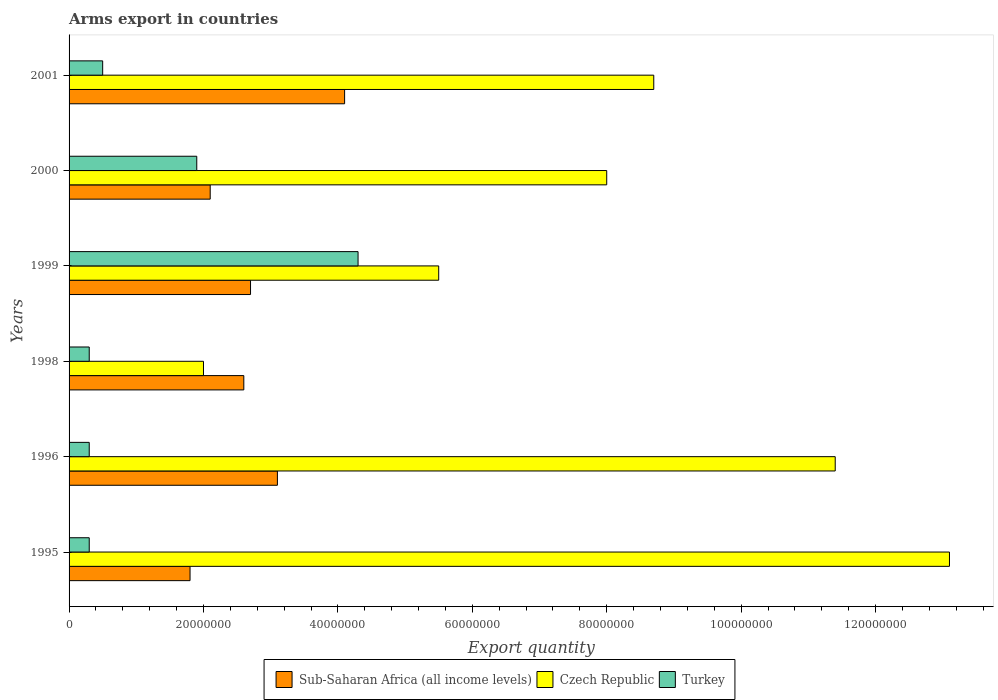How many groups of bars are there?
Give a very brief answer. 6. What is the label of the 4th group of bars from the top?
Your response must be concise. 1998. In how many cases, is the number of bars for a given year not equal to the number of legend labels?
Ensure brevity in your answer.  0. What is the total arms export in Sub-Saharan Africa (all income levels) in 1999?
Make the answer very short. 2.70e+07. Across all years, what is the maximum total arms export in Turkey?
Offer a very short reply. 4.30e+07. Across all years, what is the minimum total arms export in Sub-Saharan Africa (all income levels)?
Offer a very short reply. 1.80e+07. In which year was the total arms export in Turkey maximum?
Give a very brief answer. 1999. What is the total total arms export in Czech Republic in the graph?
Give a very brief answer. 4.87e+08. What is the difference between the total arms export in Sub-Saharan Africa (all income levels) in 2000 and that in 2001?
Your answer should be compact. -2.00e+07. What is the difference between the total arms export in Czech Republic in 2000 and the total arms export in Sub-Saharan Africa (all income levels) in 1998?
Your answer should be very brief. 5.40e+07. What is the average total arms export in Turkey per year?
Your response must be concise. 1.27e+07. In the year 1996, what is the difference between the total arms export in Czech Republic and total arms export in Turkey?
Provide a succinct answer. 1.11e+08. In how many years, is the total arms export in Turkey greater than 92000000 ?
Offer a very short reply. 0. What is the ratio of the total arms export in Sub-Saharan Africa (all income levels) in 1998 to that in 2000?
Your response must be concise. 1.24. Is the total arms export in Sub-Saharan Africa (all income levels) in 1995 less than that in 1999?
Provide a short and direct response. Yes. Is the difference between the total arms export in Czech Republic in 1995 and 1996 greater than the difference between the total arms export in Turkey in 1995 and 1996?
Provide a succinct answer. Yes. What is the difference between the highest and the second highest total arms export in Sub-Saharan Africa (all income levels)?
Offer a very short reply. 1.00e+07. What is the difference between the highest and the lowest total arms export in Sub-Saharan Africa (all income levels)?
Your answer should be compact. 2.30e+07. In how many years, is the total arms export in Czech Republic greater than the average total arms export in Czech Republic taken over all years?
Ensure brevity in your answer.  3. Is the sum of the total arms export in Turkey in 1995 and 2000 greater than the maximum total arms export in Czech Republic across all years?
Make the answer very short. No. What does the 1st bar from the top in 2000 represents?
Provide a succinct answer. Turkey. What does the 1st bar from the bottom in 2000 represents?
Offer a very short reply. Sub-Saharan Africa (all income levels). How many bars are there?
Keep it short and to the point. 18. What is the difference between two consecutive major ticks on the X-axis?
Your response must be concise. 2.00e+07. Does the graph contain grids?
Offer a very short reply. No. Where does the legend appear in the graph?
Ensure brevity in your answer.  Bottom center. How many legend labels are there?
Your answer should be very brief. 3. How are the legend labels stacked?
Your answer should be compact. Horizontal. What is the title of the graph?
Offer a very short reply. Arms export in countries. What is the label or title of the X-axis?
Make the answer very short. Export quantity. What is the Export quantity in Sub-Saharan Africa (all income levels) in 1995?
Give a very brief answer. 1.80e+07. What is the Export quantity of Czech Republic in 1995?
Provide a short and direct response. 1.31e+08. What is the Export quantity in Sub-Saharan Africa (all income levels) in 1996?
Provide a succinct answer. 3.10e+07. What is the Export quantity of Czech Republic in 1996?
Your answer should be compact. 1.14e+08. What is the Export quantity in Sub-Saharan Africa (all income levels) in 1998?
Your answer should be very brief. 2.60e+07. What is the Export quantity of Czech Republic in 1998?
Keep it short and to the point. 2.00e+07. What is the Export quantity of Sub-Saharan Africa (all income levels) in 1999?
Provide a short and direct response. 2.70e+07. What is the Export quantity of Czech Republic in 1999?
Provide a succinct answer. 5.50e+07. What is the Export quantity in Turkey in 1999?
Offer a terse response. 4.30e+07. What is the Export quantity of Sub-Saharan Africa (all income levels) in 2000?
Provide a short and direct response. 2.10e+07. What is the Export quantity of Czech Republic in 2000?
Keep it short and to the point. 8.00e+07. What is the Export quantity in Turkey in 2000?
Give a very brief answer. 1.90e+07. What is the Export quantity in Sub-Saharan Africa (all income levels) in 2001?
Your answer should be very brief. 4.10e+07. What is the Export quantity of Czech Republic in 2001?
Give a very brief answer. 8.70e+07. Across all years, what is the maximum Export quantity in Sub-Saharan Africa (all income levels)?
Your response must be concise. 4.10e+07. Across all years, what is the maximum Export quantity of Czech Republic?
Your answer should be very brief. 1.31e+08. Across all years, what is the maximum Export quantity in Turkey?
Your answer should be compact. 4.30e+07. Across all years, what is the minimum Export quantity of Sub-Saharan Africa (all income levels)?
Keep it short and to the point. 1.80e+07. Across all years, what is the minimum Export quantity of Czech Republic?
Give a very brief answer. 2.00e+07. Across all years, what is the minimum Export quantity of Turkey?
Provide a succinct answer. 3.00e+06. What is the total Export quantity in Sub-Saharan Africa (all income levels) in the graph?
Give a very brief answer. 1.64e+08. What is the total Export quantity of Czech Republic in the graph?
Provide a succinct answer. 4.87e+08. What is the total Export quantity in Turkey in the graph?
Offer a very short reply. 7.60e+07. What is the difference between the Export quantity in Sub-Saharan Africa (all income levels) in 1995 and that in 1996?
Give a very brief answer. -1.30e+07. What is the difference between the Export quantity of Czech Republic in 1995 and that in 1996?
Keep it short and to the point. 1.70e+07. What is the difference between the Export quantity in Sub-Saharan Africa (all income levels) in 1995 and that in 1998?
Ensure brevity in your answer.  -8.00e+06. What is the difference between the Export quantity in Czech Republic in 1995 and that in 1998?
Keep it short and to the point. 1.11e+08. What is the difference between the Export quantity of Turkey in 1995 and that in 1998?
Your answer should be very brief. 0. What is the difference between the Export quantity in Sub-Saharan Africa (all income levels) in 1995 and that in 1999?
Give a very brief answer. -9.00e+06. What is the difference between the Export quantity in Czech Republic in 1995 and that in 1999?
Make the answer very short. 7.60e+07. What is the difference between the Export quantity of Turkey in 1995 and that in 1999?
Provide a succinct answer. -4.00e+07. What is the difference between the Export quantity of Czech Republic in 1995 and that in 2000?
Give a very brief answer. 5.10e+07. What is the difference between the Export quantity in Turkey in 1995 and that in 2000?
Offer a terse response. -1.60e+07. What is the difference between the Export quantity of Sub-Saharan Africa (all income levels) in 1995 and that in 2001?
Provide a short and direct response. -2.30e+07. What is the difference between the Export quantity in Czech Republic in 1995 and that in 2001?
Give a very brief answer. 4.40e+07. What is the difference between the Export quantity of Turkey in 1995 and that in 2001?
Provide a short and direct response. -2.00e+06. What is the difference between the Export quantity of Czech Republic in 1996 and that in 1998?
Provide a short and direct response. 9.40e+07. What is the difference between the Export quantity in Turkey in 1996 and that in 1998?
Keep it short and to the point. 0. What is the difference between the Export quantity in Sub-Saharan Africa (all income levels) in 1996 and that in 1999?
Your answer should be very brief. 4.00e+06. What is the difference between the Export quantity of Czech Republic in 1996 and that in 1999?
Ensure brevity in your answer.  5.90e+07. What is the difference between the Export quantity in Turkey in 1996 and that in 1999?
Make the answer very short. -4.00e+07. What is the difference between the Export quantity in Czech Republic in 1996 and that in 2000?
Your answer should be compact. 3.40e+07. What is the difference between the Export quantity of Turkey in 1996 and that in 2000?
Your response must be concise. -1.60e+07. What is the difference between the Export quantity in Sub-Saharan Africa (all income levels) in 1996 and that in 2001?
Ensure brevity in your answer.  -1.00e+07. What is the difference between the Export quantity of Czech Republic in 1996 and that in 2001?
Ensure brevity in your answer.  2.70e+07. What is the difference between the Export quantity of Turkey in 1996 and that in 2001?
Offer a very short reply. -2.00e+06. What is the difference between the Export quantity of Czech Republic in 1998 and that in 1999?
Your answer should be very brief. -3.50e+07. What is the difference between the Export quantity in Turkey in 1998 and that in 1999?
Offer a very short reply. -4.00e+07. What is the difference between the Export quantity of Czech Republic in 1998 and that in 2000?
Make the answer very short. -6.00e+07. What is the difference between the Export quantity in Turkey in 1998 and that in 2000?
Provide a succinct answer. -1.60e+07. What is the difference between the Export quantity in Sub-Saharan Africa (all income levels) in 1998 and that in 2001?
Keep it short and to the point. -1.50e+07. What is the difference between the Export quantity in Czech Republic in 1998 and that in 2001?
Make the answer very short. -6.70e+07. What is the difference between the Export quantity of Czech Republic in 1999 and that in 2000?
Your response must be concise. -2.50e+07. What is the difference between the Export quantity of Turkey in 1999 and that in 2000?
Provide a succinct answer. 2.40e+07. What is the difference between the Export quantity of Sub-Saharan Africa (all income levels) in 1999 and that in 2001?
Make the answer very short. -1.40e+07. What is the difference between the Export quantity in Czech Republic in 1999 and that in 2001?
Provide a short and direct response. -3.20e+07. What is the difference between the Export quantity of Turkey in 1999 and that in 2001?
Keep it short and to the point. 3.80e+07. What is the difference between the Export quantity of Sub-Saharan Africa (all income levels) in 2000 and that in 2001?
Keep it short and to the point. -2.00e+07. What is the difference between the Export quantity in Czech Republic in 2000 and that in 2001?
Make the answer very short. -7.00e+06. What is the difference between the Export quantity in Turkey in 2000 and that in 2001?
Your answer should be very brief. 1.40e+07. What is the difference between the Export quantity in Sub-Saharan Africa (all income levels) in 1995 and the Export quantity in Czech Republic in 1996?
Offer a very short reply. -9.60e+07. What is the difference between the Export quantity in Sub-Saharan Africa (all income levels) in 1995 and the Export quantity in Turkey in 1996?
Your answer should be very brief. 1.50e+07. What is the difference between the Export quantity in Czech Republic in 1995 and the Export quantity in Turkey in 1996?
Your answer should be very brief. 1.28e+08. What is the difference between the Export quantity of Sub-Saharan Africa (all income levels) in 1995 and the Export quantity of Czech Republic in 1998?
Give a very brief answer. -2.00e+06. What is the difference between the Export quantity of Sub-Saharan Africa (all income levels) in 1995 and the Export quantity of Turkey in 1998?
Make the answer very short. 1.50e+07. What is the difference between the Export quantity of Czech Republic in 1995 and the Export quantity of Turkey in 1998?
Your answer should be compact. 1.28e+08. What is the difference between the Export quantity in Sub-Saharan Africa (all income levels) in 1995 and the Export quantity in Czech Republic in 1999?
Keep it short and to the point. -3.70e+07. What is the difference between the Export quantity in Sub-Saharan Africa (all income levels) in 1995 and the Export quantity in Turkey in 1999?
Give a very brief answer. -2.50e+07. What is the difference between the Export quantity of Czech Republic in 1995 and the Export quantity of Turkey in 1999?
Make the answer very short. 8.80e+07. What is the difference between the Export quantity in Sub-Saharan Africa (all income levels) in 1995 and the Export quantity in Czech Republic in 2000?
Your answer should be very brief. -6.20e+07. What is the difference between the Export quantity in Sub-Saharan Africa (all income levels) in 1995 and the Export quantity in Turkey in 2000?
Your answer should be very brief. -1.00e+06. What is the difference between the Export quantity in Czech Republic in 1995 and the Export quantity in Turkey in 2000?
Offer a very short reply. 1.12e+08. What is the difference between the Export quantity in Sub-Saharan Africa (all income levels) in 1995 and the Export quantity in Czech Republic in 2001?
Provide a succinct answer. -6.90e+07. What is the difference between the Export quantity in Sub-Saharan Africa (all income levels) in 1995 and the Export quantity in Turkey in 2001?
Provide a short and direct response. 1.30e+07. What is the difference between the Export quantity in Czech Republic in 1995 and the Export quantity in Turkey in 2001?
Your answer should be very brief. 1.26e+08. What is the difference between the Export quantity in Sub-Saharan Africa (all income levels) in 1996 and the Export quantity in Czech Republic in 1998?
Offer a very short reply. 1.10e+07. What is the difference between the Export quantity in Sub-Saharan Africa (all income levels) in 1996 and the Export quantity in Turkey in 1998?
Offer a very short reply. 2.80e+07. What is the difference between the Export quantity of Czech Republic in 1996 and the Export quantity of Turkey in 1998?
Ensure brevity in your answer.  1.11e+08. What is the difference between the Export quantity in Sub-Saharan Africa (all income levels) in 1996 and the Export quantity in Czech Republic in 1999?
Ensure brevity in your answer.  -2.40e+07. What is the difference between the Export quantity in Sub-Saharan Africa (all income levels) in 1996 and the Export quantity in Turkey in 1999?
Your response must be concise. -1.20e+07. What is the difference between the Export quantity in Czech Republic in 1996 and the Export quantity in Turkey in 1999?
Keep it short and to the point. 7.10e+07. What is the difference between the Export quantity in Sub-Saharan Africa (all income levels) in 1996 and the Export quantity in Czech Republic in 2000?
Keep it short and to the point. -4.90e+07. What is the difference between the Export quantity in Sub-Saharan Africa (all income levels) in 1996 and the Export quantity in Turkey in 2000?
Your response must be concise. 1.20e+07. What is the difference between the Export quantity of Czech Republic in 1996 and the Export quantity of Turkey in 2000?
Keep it short and to the point. 9.50e+07. What is the difference between the Export quantity of Sub-Saharan Africa (all income levels) in 1996 and the Export quantity of Czech Republic in 2001?
Offer a terse response. -5.60e+07. What is the difference between the Export quantity in Sub-Saharan Africa (all income levels) in 1996 and the Export quantity in Turkey in 2001?
Offer a terse response. 2.60e+07. What is the difference between the Export quantity in Czech Republic in 1996 and the Export quantity in Turkey in 2001?
Make the answer very short. 1.09e+08. What is the difference between the Export quantity in Sub-Saharan Africa (all income levels) in 1998 and the Export quantity in Czech Republic in 1999?
Ensure brevity in your answer.  -2.90e+07. What is the difference between the Export quantity of Sub-Saharan Africa (all income levels) in 1998 and the Export quantity of Turkey in 1999?
Provide a short and direct response. -1.70e+07. What is the difference between the Export quantity in Czech Republic in 1998 and the Export quantity in Turkey in 1999?
Make the answer very short. -2.30e+07. What is the difference between the Export quantity in Sub-Saharan Africa (all income levels) in 1998 and the Export quantity in Czech Republic in 2000?
Provide a succinct answer. -5.40e+07. What is the difference between the Export quantity in Sub-Saharan Africa (all income levels) in 1998 and the Export quantity in Turkey in 2000?
Offer a very short reply. 7.00e+06. What is the difference between the Export quantity in Sub-Saharan Africa (all income levels) in 1998 and the Export quantity in Czech Republic in 2001?
Give a very brief answer. -6.10e+07. What is the difference between the Export quantity of Sub-Saharan Africa (all income levels) in 1998 and the Export quantity of Turkey in 2001?
Your answer should be compact. 2.10e+07. What is the difference between the Export quantity in Czech Republic in 1998 and the Export quantity in Turkey in 2001?
Your response must be concise. 1.50e+07. What is the difference between the Export quantity of Sub-Saharan Africa (all income levels) in 1999 and the Export quantity of Czech Republic in 2000?
Offer a very short reply. -5.30e+07. What is the difference between the Export quantity of Czech Republic in 1999 and the Export quantity of Turkey in 2000?
Offer a very short reply. 3.60e+07. What is the difference between the Export quantity in Sub-Saharan Africa (all income levels) in 1999 and the Export quantity in Czech Republic in 2001?
Offer a terse response. -6.00e+07. What is the difference between the Export quantity of Sub-Saharan Africa (all income levels) in 1999 and the Export quantity of Turkey in 2001?
Ensure brevity in your answer.  2.20e+07. What is the difference between the Export quantity in Sub-Saharan Africa (all income levels) in 2000 and the Export quantity in Czech Republic in 2001?
Provide a succinct answer. -6.60e+07. What is the difference between the Export quantity in Sub-Saharan Africa (all income levels) in 2000 and the Export quantity in Turkey in 2001?
Make the answer very short. 1.60e+07. What is the difference between the Export quantity in Czech Republic in 2000 and the Export quantity in Turkey in 2001?
Make the answer very short. 7.50e+07. What is the average Export quantity in Sub-Saharan Africa (all income levels) per year?
Make the answer very short. 2.73e+07. What is the average Export quantity of Czech Republic per year?
Keep it short and to the point. 8.12e+07. What is the average Export quantity in Turkey per year?
Provide a succinct answer. 1.27e+07. In the year 1995, what is the difference between the Export quantity of Sub-Saharan Africa (all income levels) and Export quantity of Czech Republic?
Offer a very short reply. -1.13e+08. In the year 1995, what is the difference between the Export quantity of Sub-Saharan Africa (all income levels) and Export quantity of Turkey?
Keep it short and to the point. 1.50e+07. In the year 1995, what is the difference between the Export quantity of Czech Republic and Export quantity of Turkey?
Offer a very short reply. 1.28e+08. In the year 1996, what is the difference between the Export quantity of Sub-Saharan Africa (all income levels) and Export quantity of Czech Republic?
Your response must be concise. -8.30e+07. In the year 1996, what is the difference between the Export quantity of Sub-Saharan Africa (all income levels) and Export quantity of Turkey?
Provide a short and direct response. 2.80e+07. In the year 1996, what is the difference between the Export quantity of Czech Republic and Export quantity of Turkey?
Offer a very short reply. 1.11e+08. In the year 1998, what is the difference between the Export quantity in Sub-Saharan Africa (all income levels) and Export quantity in Czech Republic?
Your response must be concise. 6.00e+06. In the year 1998, what is the difference between the Export quantity of Sub-Saharan Africa (all income levels) and Export quantity of Turkey?
Provide a succinct answer. 2.30e+07. In the year 1998, what is the difference between the Export quantity in Czech Republic and Export quantity in Turkey?
Your answer should be very brief. 1.70e+07. In the year 1999, what is the difference between the Export quantity of Sub-Saharan Africa (all income levels) and Export quantity of Czech Republic?
Give a very brief answer. -2.80e+07. In the year 1999, what is the difference between the Export quantity of Sub-Saharan Africa (all income levels) and Export quantity of Turkey?
Make the answer very short. -1.60e+07. In the year 2000, what is the difference between the Export quantity of Sub-Saharan Africa (all income levels) and Export quantity of Czech Republic?
Your response must be concise. -5.90e+07. In the year 2000, what is the difference between the Export quantity of Czech Republic and Export quantity of Turkey?
Provide a succinct answer. 6.10e+07. In the year 2001, what is the difference between the Export quantity in Sub-Saharan Africa (all income levels) and Export quantity in Czech Republic?
Offer a terse response. -4.60e+07. In the year 2001, what is the difference between the Export quantity in Sub-Saharan Africa (all income levels) and Export quantity in Turkey?
Ensure brevity in your answer.  3.60e+07. In the year 2001, what is the difference between the Export quantity in Czech Republic and Export quantity in Turkey?
Offer a terse response. 8.20e+07. What is the ratio of the Export quantity of Sub-Saharan Africa (all income levels) in 1995 to that in 1996?
Provide a succinct answer. 0.58. What is the ratio of the Export quantity of Czech Republic in 1995 to that in 1996?
Your answer should be compact. 1.15. What is the ratio of the Export quantity of Sub-Saharan Africa (all income levels) in 1995 to that in 1998?
Ensure brevity in your answer.  0.69. What is the ratio of the Export quantity in Czech Republic in 1995 to that in 1998?
Ensure brevity in your answer.  6.55. What is the ratio of the Export quantity of Czech Republic in 1995 to that in 1999?
Provide a short and direct response. 2.38. What is the ratio of the Export quantity of Turkey in 1995 to that in 1999?
Make the answer very short. 0.07. What is the ratio of the Export quantity of Sub-Saharan Africa (all income levels) in 1995 to that in 2000?
Ensure brevity in your answer.  0.86. What is the ratio of the Export quantity in Czech Republic in 1995 to that in 2000?
Your answer should be compact. 1.64. What is the ratio of the Export quantity in Turkey in 1995 to that in 2000?
Your answer should be very brief. 0.16. What is the ratio of the Export quantity in Sub-Saharan Africa (all income levels) in 1995 to that in 2001?
Your answer should be very brief. 0.44. What is the ratio of the Export quantity of Czech Republic in 1995 to that in 2001?
Your answer should be compact. 1.51. What is the ratio of the Export quantity in Sub-Saharan Africa (all income levels) in 1996 to that in 1998?
Provide a succinct answer. 1.19. What is the ratio of the Export quantity in Czech Republic in 1996 to that in 1998?
Your answer should be very brief. 5.7. What is the ratio of the Export quantity of Sub-Saharan Africa (all income levels) in 1996 to that in 1999?
Offer a very short reply. 1.15. What is the ratio of the Export quantity of Czech Republic in 1996 to that in 1999?
Keep it short and to the point. 2.07. What is the ratio of the Export quantity of Turkey in 1996 to that in 1999?
Provide a short and direct response. 0.07. What is the ratio of the Export quantity of Sub-Saharan Africa (all income levels) in 1996 to that in 2000?
Make the answer very short. 1.48. What is the ratio of the Export quantity in Czech Republic in 1996 to that in 2000?
Your response must be concise. 1.43. What is the ratio of the Export quantity of Turkey in 1996 to that in 2000?
Offer a terse response. 0.16. What is the ratio of the Export quantity in Sub-Saharan Africa (all income levels) in 1996 to that in 2001?
Provide a succinct answer. 0.76. What is the ratio of the Export quantity in Czech Republic in 1996 to that in 2001?
Your response must be concise. 1.31. What is the ratio of the Export quantity in Turkey in 1996 to that in 2001?
Offer a very short reply. 0.6. What is the ratio of the Export quantity of Czech Republic in 1998 to that in 1999?
Your response must be concise. 0.36. What is the ratio of the Export quantity of Turkey in 1998 to that in 1999?
Offer a terse response. 0.07. What is the ratio of the Export quantity in Sub-Saharan Africa (all income levels) in 1998 to that in 2000?
Provide a succinct answer. 1.24. What is the ratio of the Export quantity of Czech Republic in 1998 to that in 2000?
Provide a short and direct response. 0.25. What is the ratio of the Export quantity in Turkey in 1998 to that in 2000?
Ensure brevity in your answer.  0.16. What is the ratio of the Export quantity in Sub-Saharan Africa (all income levels) in 1998 to that in 2001?
Your answer should be compact. 0.63. What is the ratio of the Export quantity in Czech Republic in 1998 to that in 2001?
Give a very brief answer. 0.23. What is the ratio of the Export quantity in Turkey in 1998 to that in 2001?
Offer a very short reply. 0.6. What is the ratio of the Export quantity in Czech Republic in 1999 to that in 2000?
Your response must be concise. 0.69. What is the ratio of the Export quantity of Turkey in 1999 to that in 2000?
Make the answer very short. 2.26. What is the ratio of the Export quantity in Sub-Saharan Africa (all income levels) in 1999 to that in 2001?
Offer a terse response. 0.66. What is the ratio of the Export quantity in Czech Republic in 1999 to that in 2001?
Your response must be concise. 0.63. What is the ratio of the Export quantity in Turkey in 1999 to that in 2001?
Make the answer very short. 8.6. What is the ratio of the Export quantity in Sub-Saharan Africa (all income levels) in 2000 to that in 2001?
Ensure brevity in your answer.  0.51. What is the ratio of the Export quantity in Czech Republic in 2000 to that in 2001?
Your answer should be compact. 0.92. What is the difference between the highest and the second highest Export quantity of Sub-Saharan Africa (all income levels)?
Give a very brief answer. 1.00e+07. What is the difference between the highest and the second highest Export quantity of Czech Republic?
Your response must be concise. 1.70e+07. What is the difference between the highest and the second highest Export quantity of Turkey?
Offer a terse response. 2.40e+07. What is the difference between the highest and the lowest Export quantity in Sub-Saharan Africa (all income levels)?
Your answer should be compact. 2.30e+07. What is the difference between the highest and the lowest Export quantity in Czech Republic?
Offer a very short reply. 1.11e+08. What is the difference between the highest and the lowest Export quantity of Turkey?
Your response must be concise. 4.00e+07. 